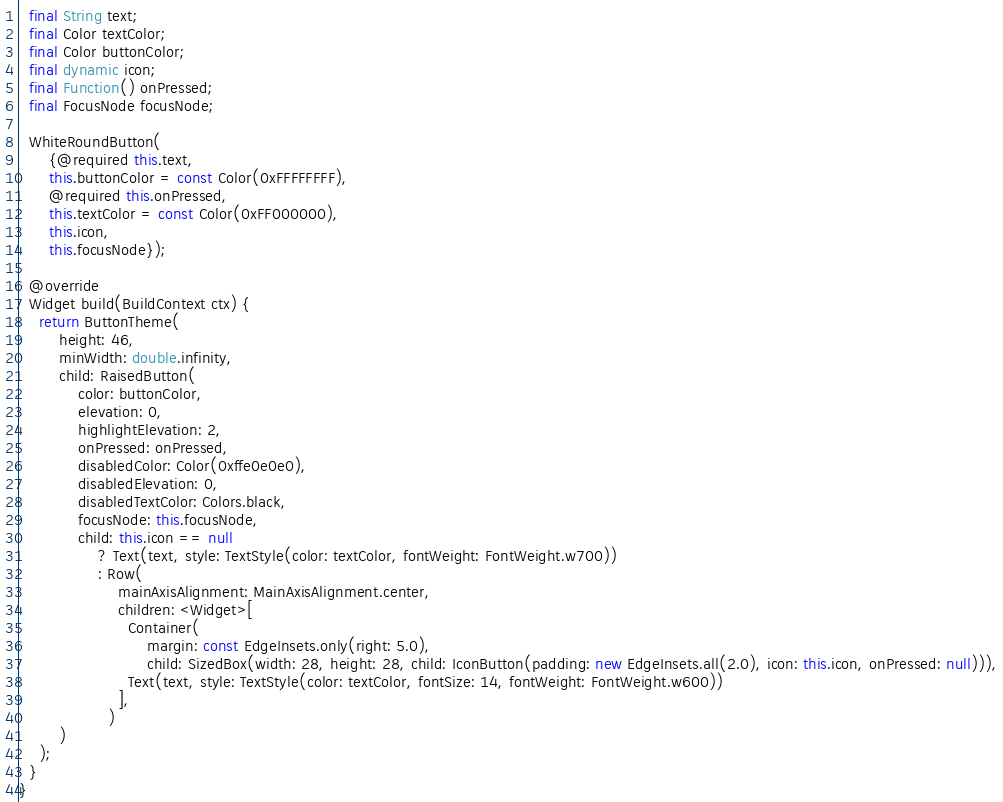<code> <loc_0><loc_0><loc_500><loc_500><_Dart_>  final String text;
  final Color textColor;
  final Color buttonColor;
  final dynamic icon;
  final Function() onPressed;
  final FocusNode focusNode;

  WhiteRoundButton(
      {@required this.text,
      this.buttonColor = const Color(0xFFFFFFFF),
      @required this.onPressed,
      this.textColor = const Color(0xFF000000),
      this.icon,
      this.focusNode});

  @override
  Widget build(BuildContext ctx) {
    return ButtonTheme(
        height: 46,
        minWidth: double.infinity,
        child: RaisedButton(
            color: buttonColor,
            elevation: 0,
            highlightElevation: 2,
            onPressed: onPressed,
            disabledColor: Color(0xffe0e0e0),
            disabledElevation: 0,
            disabledTextColor: Colors.black,
            focusNode: this.focusNode,
            child: this.icon == null
                ? Text(text, style: TextStyle(color: textColor, fontWeight: FontWeight.w700))
                : Row(
                    mainAxisAlignment: MainAxisAlignment.center,
                    children: <Widget>[
                      Container(
                          margin: const EdgeInsets.only(right: 5.0),
                          child: SizedBox(width: 28, height: 28, child: IconButton(padding: new EdgeInsets.all(2.0), icon: this.icon, onPressed: null))),
                      Text(text, style: TextStyle(color: textColor, fontSize: 14, fontWeight: FontWeight.w600))
                    ],
                  )
        )
    );
  }
}
</code> 